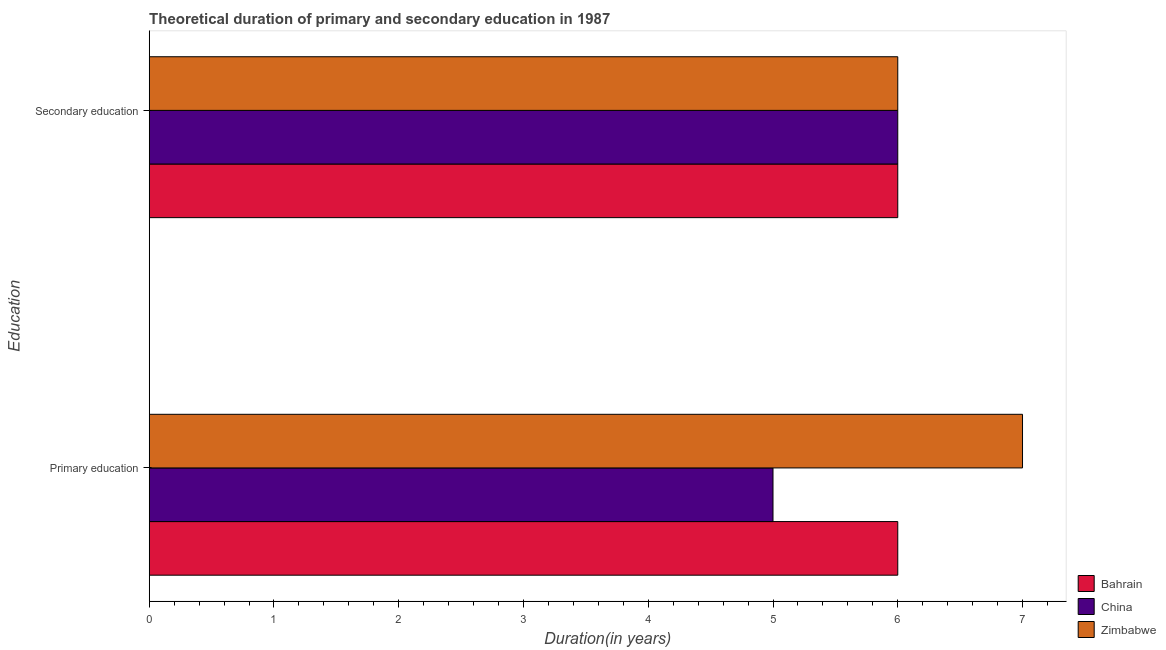Are the number of bars per tick equal to the number of legend labels?
Offer a terse response. Yes. How many bars are there on the 1st tick from the top?
Make the answer very short. 3. Across all countries, what is the maximum duration of primary education?
Offer a terse response. 7. Across all countries, what is the minimum duration of primary education?
Ensure brevity in your answer.  5. In which country was the duration of primary education maximum?
Ensure brevity in your answer.  Zimbabwe. In which country was the duration of secondary education minimum?
Offer a terse response. Bahrain. What is the total duration of primary education in the graph?
Offer a very short reply. 18. What is the difference between the duration of primary education in Bahrain and that in China?
Make the answer very short. 1. What is the difference between the duration of primary education in China and the duration of secondary education in Zimbabwe?
Your answer should be compact. -1. What is the difference between the duration of primary education and duration of secondary education in Zimbabwe?
Your answer should be very brief. 1. In how many countries, is the duration of secondary education greater than 7 years?
Make the answer very short. 0. What is the ratio of the duration of primary education in China to that in Bahrain?
Your answer should be very brief. 0.83. Is the duration of secondary education in Bahrain less than that in Zimbabwe?
Keep it short and to the point. No. What does the 1st bar from the top in Secondary education represents?
Keep it short and to the point. Zimbabwe. What does the 3rd bar from the bottom in Secondary education represents?
Your answer should be compact. Zimbabwe. Are all the bars in the graph horizontal?
Ensure brevity in your answer.  Yes. How many countries are there in the graph?
Your answer should be very brief. 3. Where does the legend appear in the graph?
Provide a short and direct response. Bottom right. How many legend labels are there?
Give a very brief answer. 3. What is the title of the graph?
Provide a succinct answer. Theoretical duration of primary and secondary education in 1987. What is the label or title of the X-axis?
Give a very brief answer. Duration(in years). What is the label or title of the Y-axis?
Ensure brevity in your answer.  Education. What is the Duration(in years) in Zimbabwe in Primary education?
Provide a short and direct response. 7. What is the Duration(in years) in Zimbabwe in Secondary education?
Offer a terse response. 6. What is the total Duration(in years) of Zimbabwe in the graph?
Offer a terse response. 13. What is the difference between the Duration(in years) of Zimbabwe in Primary education and that in Secondary education?
Provide a short and direct response. 1. What is the difference between the Duration(in years) in Bahrain in Primary education and the Duration(in years) in China in Secondary education?
Your answer should be very brief. 0. What is the average Duration(in years) of China per Education?
Your response must be concise. 5.5. What is the average Duration(in years) in Zimbabwe per Education?
Give a very brief answer. 6.5. What is the difference between the Duration(in years) of Bahrain and Duration(in years) of China in Primary education?
Keep it short and to the point. 1. What is the difference between the Duration(in years) in China and Duration(in years) in Zimbabwe in Primary education?
Keep it short and to the point. -2. What is the difference between the Duration(in years) of Bahrain and Duration(in years) of China in Secondary education?
Your answer should be compact. 0. What is the difference between the Duration(in years) of Bahrain and Duration(in years) of Zimbabwe in Secondary education?
Keep it short and to the point. 0. What is the ratio of the Duration(in years) in China in Primary education to that in Secondary education?
Make the answer very short. 0.83. What is the ratio of the Duration(in years) of Zimbabwe in Primary education to that in Secondary education?
Make the answer very short. 1.17. What is the difference between the highest and the second highest Duration(in years) of China?
Offer a terse response. 1. What is the difference between the highest and the second highest Duration(in years) in Zimbabwe?
Provide a succinct answer. 1. What is the difference between the highest and the lowest Duration(in years) of China?
Your response must be concise. 1. What is the difference between the highest and the lowest Duration(in years) of Zimbabwe?
Provide a short and direct response. 1. 